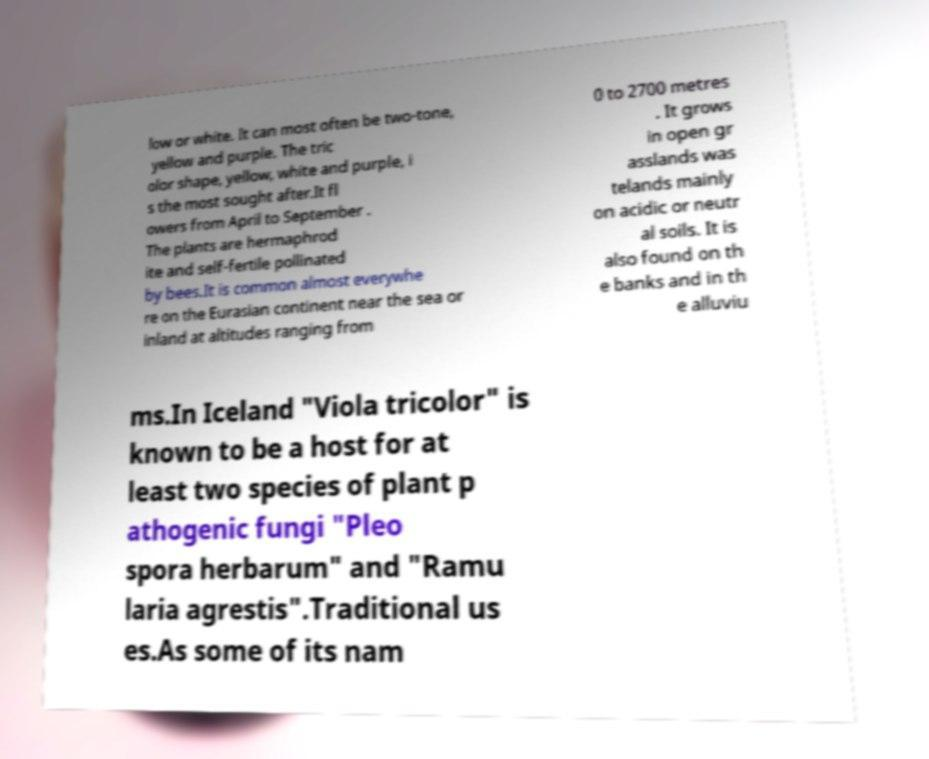Please read and relay the text visible in this image. What does it say? low or white. It can most often be two-tone, yellow and purple. The tric olor shape, yellow, white and purple, i s the most sought after.It fl owers from April to September . The plants are hermaphrod ite and self-fertile pollinated by bees.It is common almost everywhe re on the Eurasian continent near the sea or inland at altitudes ranging from 0 to 2700 metres . It grows in open gr asslands was telands mainly on acidic or neutr al soils. It is also found on th e banks and in th e alluviu ms.In Iceland "Viola tricolor" is known to be a host for at least two species of plant p athogenic fungi "Pleo spora herbarum" and "Ramu laria agrestis".Traditional us es.As some of its nam 